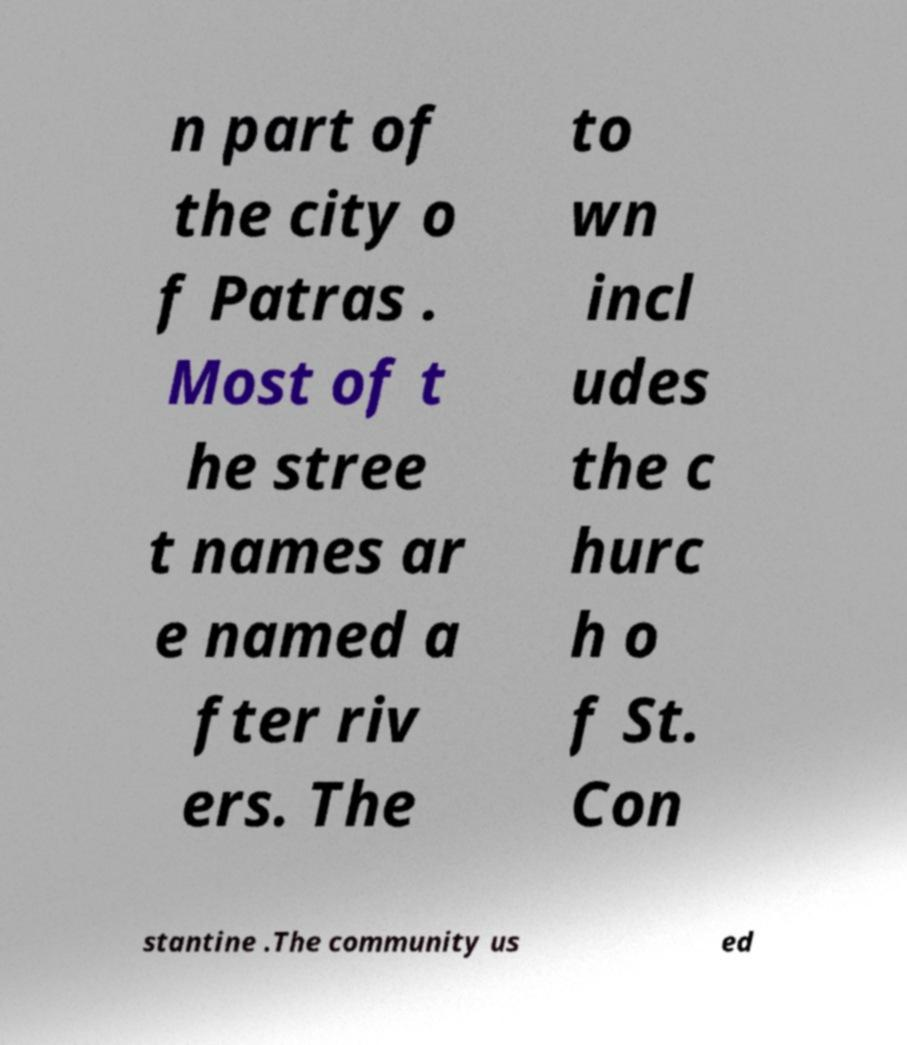Please identify and transcribe the text found in this image. n part of the city o f Patras . Most of t he stree t names ar e named a fter riv ers. The to wn incl udes the c hurc h o f St. Con stantine .The community us ed 